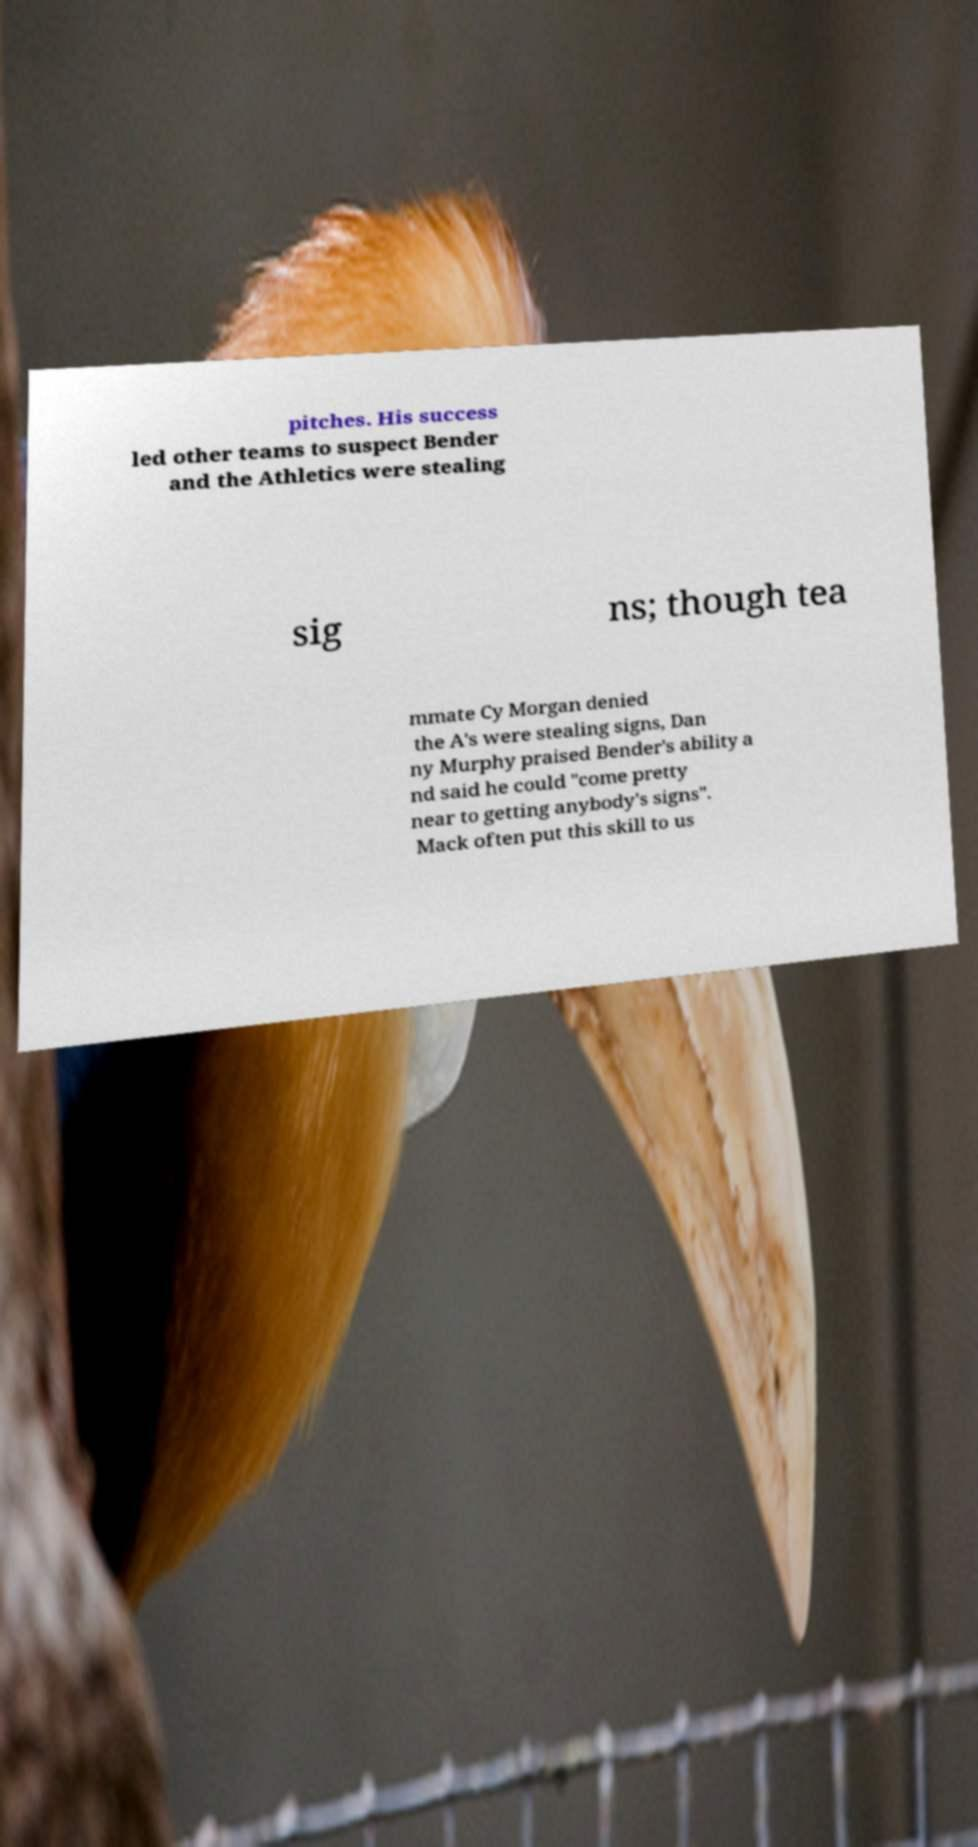Please identify and transcribe the text found in this image. pitches. His success led other teams to suspect Bender and the Athletics were stealing sig ns; though tea mmate Cy Morgan denied the A's were stealing signs, Dan ny Murphy praised Bender's ability a nd said he could "come pretty near to getting anybody's signs". Mack often put this skill to us 